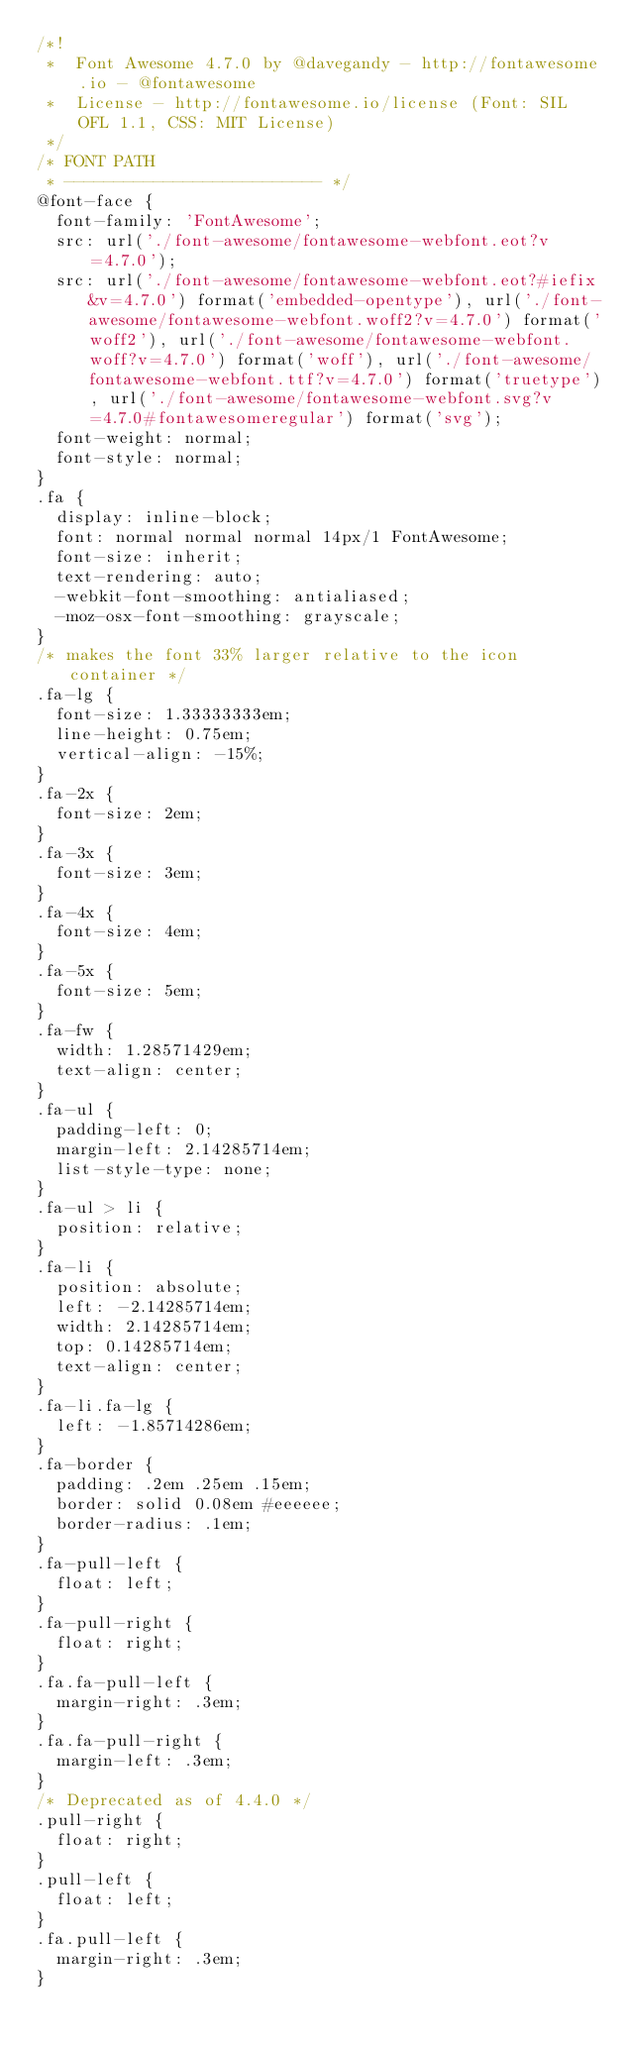<code> <loc_0><loc_0><loc_500><loc_500><_CSS_>/*!
 *  Font Awesome 4.7.0 by @davegandy - http://fontawesome.io - @fontawesome
 *  License - http://fontawesome.io/license (Font: SIL OFL 1.1, CSS: MIT License)
 */
/* FONT PATH
 * -------------------------- */
@font-face {
  font-family: 'FontAwesome';
  src: url('./font-awesome/fontawesome-webfont.eot?v=4.7.0');
  src: url('./font-awesome/fontawesome-webfont.eot?#iefix&v=4.7.0') format('embedded-opentype'), url('./font-awesome/fontawesome-webfont.woff2?v=4.7.0') format('woff2'), url('./font-awesome/fontawesome-webfont.woff?v=4.7.0') format('woff'), url('./font-awesome/fontawesome-webfont.ttf?v=4.7.0') format('truetype'), url('./font-awesome/fontawesome-webfont.svg?v=4.7.0#fontawesomeregular') format('svg');
  font-weight: normal;
  font-style: normal;
}
.fa {
  display: inline-block;
  font: normal normal normal 14px/1 FontAwesome;
  font-size: inherit;
  text-rendering: auto;
  -webkit-font-smoothing: antialiased;
  -moz-osx-font-smoothing: grayscale;
}
/* makes the font 33% larger relative to the icon container */
.fa-lg {
  font-size: 1.33333333em;
  line-height: 0.75em;
  vertical-align: -15%;
}
.fa-2x {
  font-size: 2em;
}
.fa-3x {
  font-size: 3em;
}
.fa-4x {
  font-size: 4em;
}
.fa-5x {
  font-size: 5em;
}
.fa-fw {
  width: 1.28571429em;
  text-align: center;
}
.fa-ul {
  padding-left: 0;
  margin-left: 2.14285714em;
  list-style-type: none;
}
.fa-ul > li {
  position: relative;
}
.fa-li {
  position: absolute;
  left: -2.14285714em;
  width: 2.14285714em;
  top: 0.14285714em;
  text-align: center;
}
.fa-li.fa-lg {
  left: -1.85714286em;
}
.fa-border {
  padding: .2em .25em .15em;
  border: solid 0.08em #eeeeee;
  border-radius: .1em;
}
.fa-pull-left {
  float: left;
}
.fa-pull-right {
  float: right;
}
.fa.fa-pull-left {
  margin-right: .3em;
}
.fa.fa-pull-right {
  margin-left: .3em;
}
/* Deprecated as of 4.4.0 */
.pull-right {
  float: right;
}
.pull-left {
  float: left;
}
.fa.pull-left {
  margin-right: .3em;
}</code> 